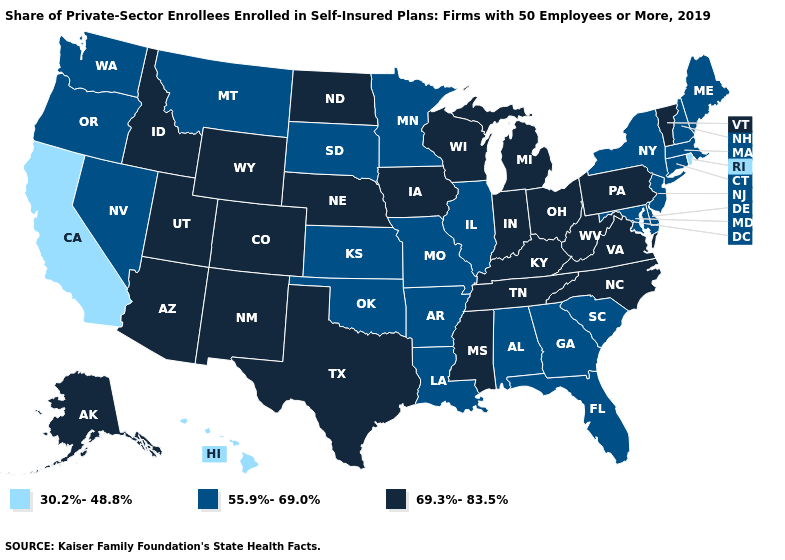Among the states that border Minnesota , which have the lowest value?
Quick response, please. South Dakota. What is the value of West Virginia?
Keep it brief. 69.3%-83.5%. Name the states that have a value in the range 69.3%-83.5%?
Short answer required. Alaska, Arizona, Colorado, Idaho, Indiana, Iowa, Kentucky, Michigan, Mississippi, Nebraska, New Mexico, North Carolina, North Dakota, Ohio, Pennsylvania, Tennessee, Texas, Utah, Vermont, Virginia, West Virginia, Wisconsin, Wyoming. Name the states that have a value in the range 69.3%-83.5%?
Be succinct. Alaska, Arizona, Colorado, Idaho, Indiana, Iowa, Kentucky, Michigan, Mississippi, Nebraska, New Mexico, North Carolina, North Dakota, Ohio, Pennsylvania, Tennessee, Texas, Utah, Vermont, Virginia, West Virginia, Wisconsin, Wyoming. What is the lowest value in states that border Texas?
Write a very short answer. 55.9%-69.0%. What is the value of Washington?
Be succinct. 55.9%-69.0%. What is the lowest value in the USA?
Short answer required. 30.2%-48.8%. Name the states that have a value in the range 55.9%-69.0%?
Give a very brief answer. Alabama, Arkansas, Connecticut, Delaware, Florida, Georgia, Illinois, Kansas, Louisiana, Maine, Maryland, Massachusetts, Minnesota, Missouri, Montana, Nevada, New Hampshire, New Jersey, New York, Oklahoma, Oregon, South Carolina, South Dakota, Washington. Name the states that have a value in the range 30.2%-48.8%?
Quick response, please. California, Hawaii, Rhode Island. What is the value of Colorado?
Concise answer only. 69.3%-83.5%. Name the states that have a value in the range 30.2%-48.8%?
Be succinct. California, Hawaii, Rhode Island. Does Connecticut have a higher value than New York?
Quick response, please. No. What is the value of Delaware?
Be succinct. 55.9%-69.0%. What is the lowest value in the Northeast?
Write a very short answer. 30.2%-48.8%. Does California have the highest value in the West?
Be succinct. No. 